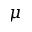<formula> <loc_0><loc_0><loc_500><loc_500>\mu</formula> 